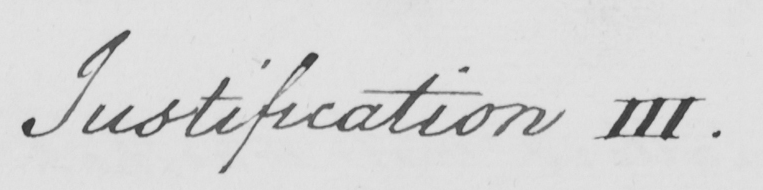Can you read and transcribe this handwriting? Justification III . 